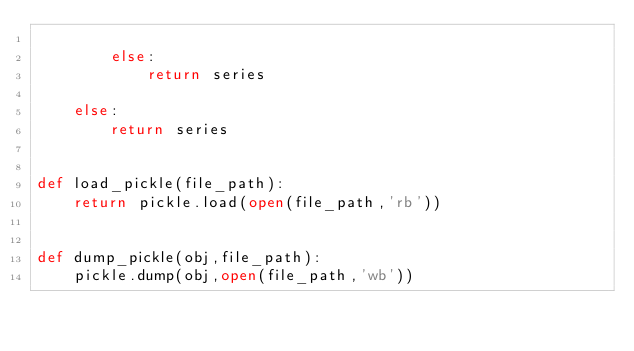Convert code to text. <code><loc_0><loc_0><loc_500><loc_500><_Python_>       
        else:
            return series
            
    else:
        return series
    

def load_pickle(file_path):
    return pickle.load(open(file_path,'rb'))
    
    
def dump_pickle(obj,file_path):
    pickle.dump(obj,open(file_path,'wb'))</code> 